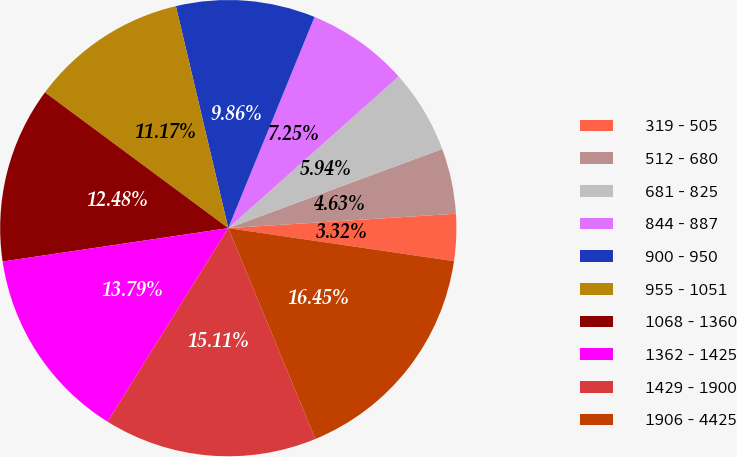Convert chart. <chart><loc_0><loc_0><loc_500><loc_500><pie_chart><fcel>319 - 505<fcel>512 - 680<fcel>681 - 825<fcel>844 - 887<fcel>900 - 950<fcel>955 - 1051<fcel>1068 - 1360<fcel>1362 - 1425<fcel>1429 - 1900<fcel>1906 - 4425<nl><fcel>3.32%<fcel>4.63%<fcel>5.94%<fcel>7.25%<fcel>9.86%<fcel>11.17%<fcel>12.48%<fcel>13.79%<fcel>15.11%<fcel>16.45%<nl></chart> 